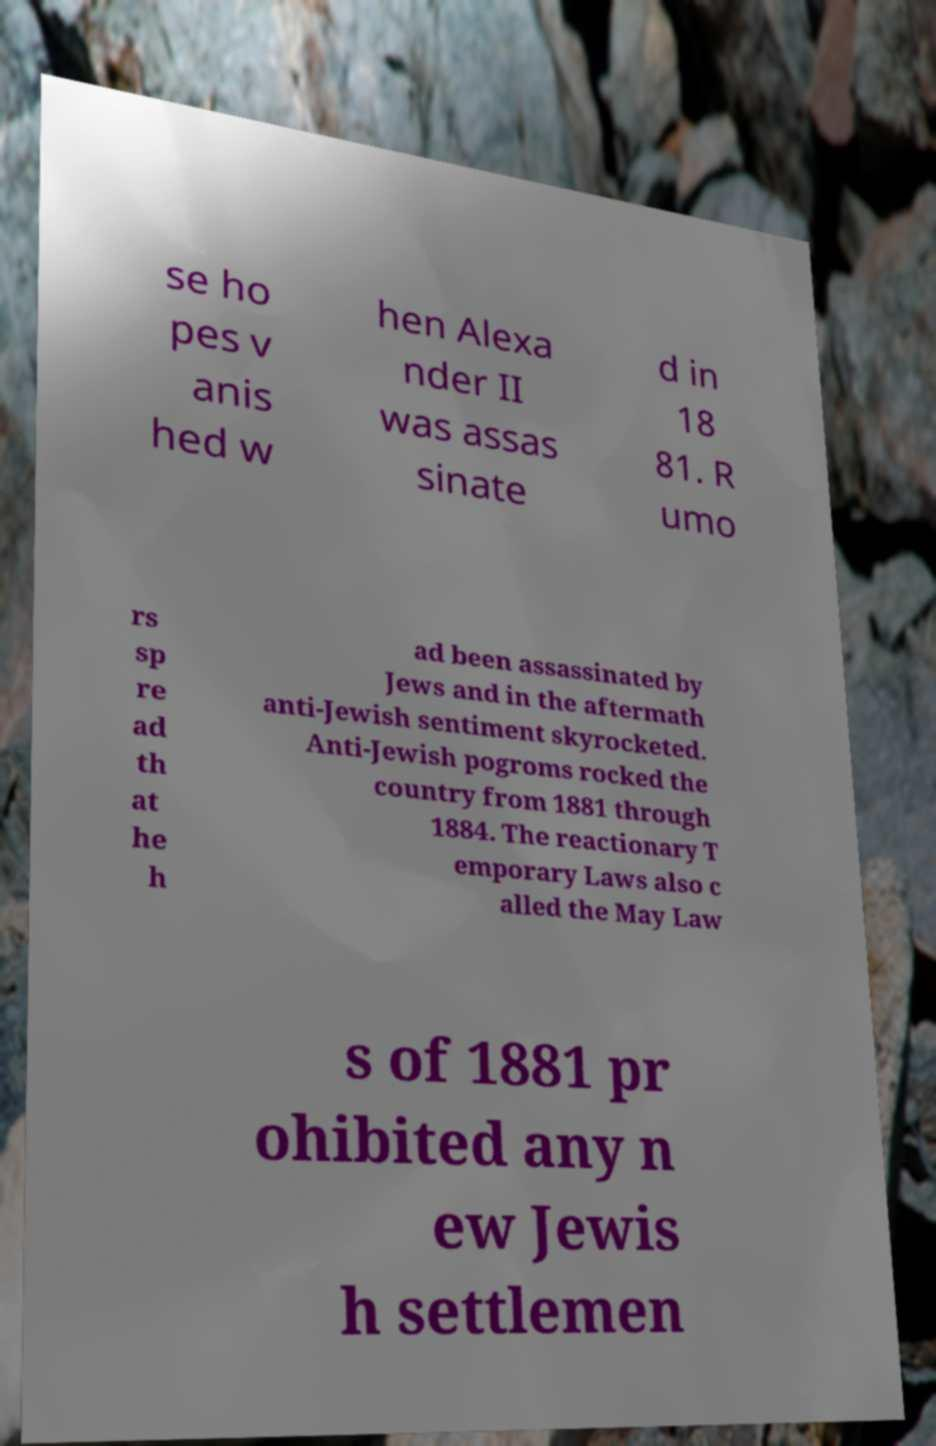Please identify and transcribe the text found in this image. se ho pes v anis hed w hen Alexa nder II was assas sinate d in 18 81. R umo rs sp re ad th at he h ad been assassinated by Jews and in the aftermath anti-Jewish sentiment skyrocketed. Anti-Jewish pogroms rocked the country from 1881 through 1884. The reactionary T emporary Laws also c alled the May Law s of 1881 pr ohibited any n ew Jewis h settlemen 